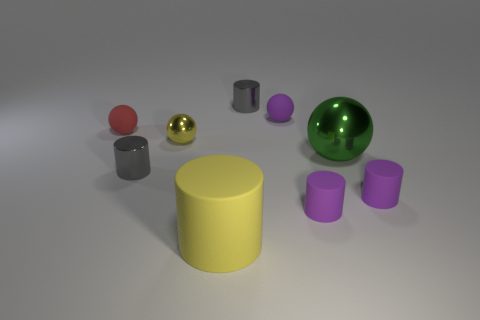The gray cylinder on the left side of the cylinder that is behind the matte ball that is behind the small red object is made of what material? The gray cylinder appears to have a reflective surface suggesting that it could be made of a polished metal, which allows light to bounce off its surface, giving it a shine that is characteristic of metallic objects. 